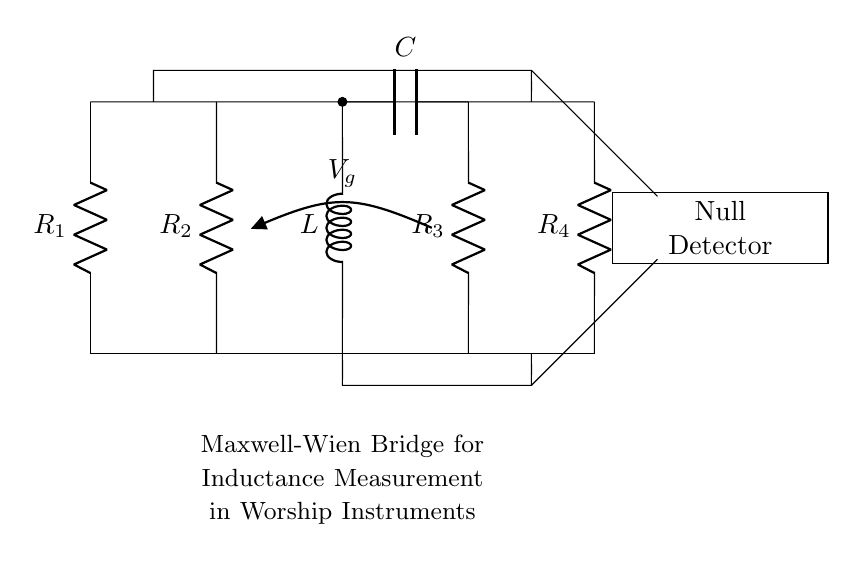What type of bridge is used in this circuit? The circuit represents a Maxwell-Wien bridge, which is specifically designed for precise inductance measurements. The naming indicates it is a variant of the Wien bridge adapted for inductors.
Answer: Maxwell-Wien What is the primary component being measured? The inductor is the main component being measured in this circuit. It is indicated by the label 'L' in the diagram, suggesting that the goal is to determine its inductance value accurately.
Answer: Inductor How many resistors are present in the circuit? There are four resistors labeled as R1, R2, R3, and R4 in the diagram. Counting these components directly from the visual confirms that there are indeed four.
Answer: Four What type of only active component is present between R2 and R3? The circuit contains a capacitor labeled 'C' located between R2 and R3. This placement is essential for the functionality of the bridge in measuring inductance.
Answer: Capacitor What is the purpose of the null detector in this circuit? The null detector is used to determine when the bridge is balanced, indicating that the measured inductance is equal to the reference values. It helps in achieving precise measurements by identifying the null point in the circuit.
Answer: Measure balance What is the role of the voltage source labeled Vg? Vg acts as the excitation source for the bridge circuit, providing the necessary voltage to establish a potential difference and enabling the measurement process by comparing against the other circuit elements.
Answer: Excitation source 